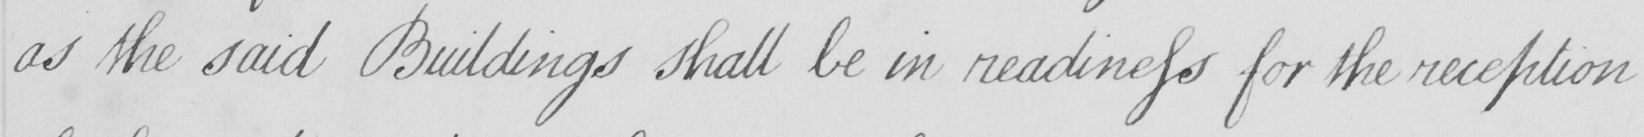What does this handwritten line say? as the said Buildings shall be in readiness for the reception 